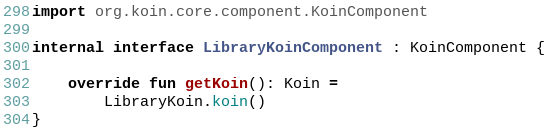<code> <loc_0><loc_0><loc_500><loc_500><_Kotlin_>import org.koin.core.component.KoinComponent

internal interface LibraryKoinComponent : KoinComponent {

    override fun getKoin(): Koin =
        LibraryKoin.koin()
}
</code> 